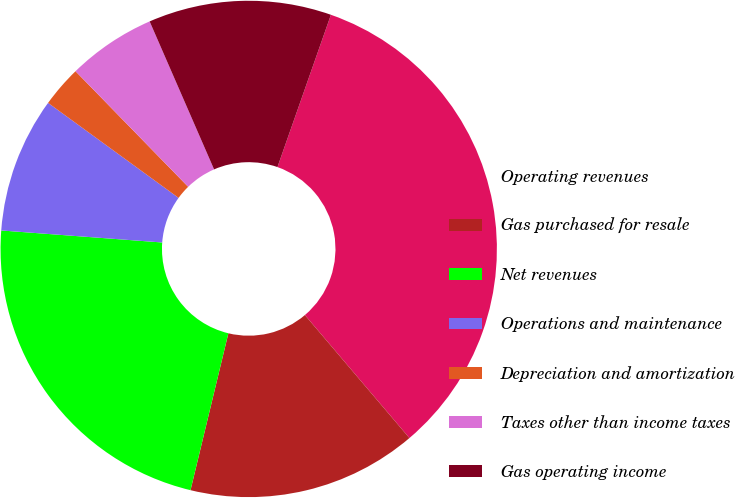<chart> <loc_0><loc_0><loc_500><loc_500><pie_chart><fcel>Operating revenues<fcel>Gas purchased for resale<fcel>Net revenues<fcel>Operations and maintenance<fcel>Depreciation and amortization<fcel>Taxes other than income taxes<fcel>Gas operating income<nl><fcel>33.42%<fcel>14.98%<fcel>22.42%<fcel>8.83%<fcel>2.69%<fcel>5.76%<fcel>11.91%<nl></chart> 